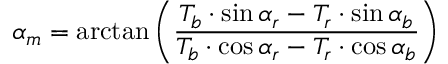Convert formula to latex. <formula><loc_0><loc_0><loc_500><loc_500>\alpha _ { m } = \arctan \left ( { \frac { T _ { b } \cdot \sin \alpha _ { r } - T _ { r } \cdot \sin \alpha _ { b } } { T _ { b } \cdot \cos \alpha _ { r } - T _ { r } \cdot \cos \alpha _ { b } } } \right )</formula> 